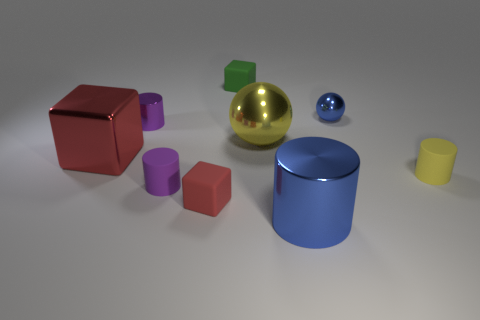Subtract all big cylinders. How many cylinders are left? 3 Subtract 2 cylinders. How many cylinders are left? 2 Subtract all cylinders. How many objects are left? 5 Subtract all blue cylinders. How many cylinders are left? 3 Add 5 big yellow spheres. How many big yellow spheres exist? 6 Add 1 blue metal spheres. How many objects exist? 10 Subtract 0 brown blocks. How many objects are left? 9 Subtract all red cubes. Subtract all purple cylinders. How many cubes are left? 1 Subtract all cyan blocks. How many yellow spheres are left? 1 Subtract all blue matte cylinders. Subtract all big blue cylinders. How many objects are left? 8 